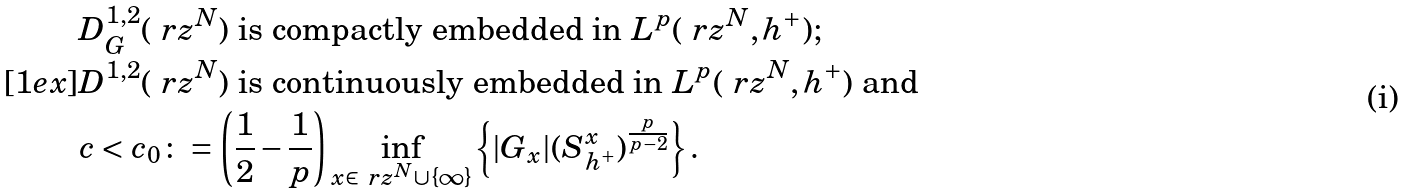<formula> <loc_0><loc_0><loc_500><loc_500>& D ^ { 1 , 2 } _ { G } ( \ r z ^ { N } ) \text { is compactly embedded in } L ^ { p } ( \ r z ^ { N } , h ^ { + } ) ; \\ [ 1 e x ] & D ^ { 1 , 2 } ( \ r z ^ { N } ) \text { is continuously embedded in } L ^ { p } ( \ r z ^ { N } , h ^ { + } ) \text { and } \\ & c < c _ { 0 } \colon = \left ( \frac { 1 } { 2 } - \frac { 1 } { p } \right ) \inf _ { x \in \ r z ^ { N } \cup \{ \infty \} } \left \{ | G _ { x } | ( S ^ { x } _ { h ^ { + } } ) ^ { \frac { p } { p - 2 } } \right \} .</formula> 